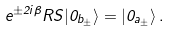<formula> <loc_0><loc_0><loc_500><loc_500>e ^ { \pm 2 i \beta } R S | 0 _ { b _ { \pm } } \rangle = | 0 _ { a _ { \pm } } \rangle \, .</formula> 